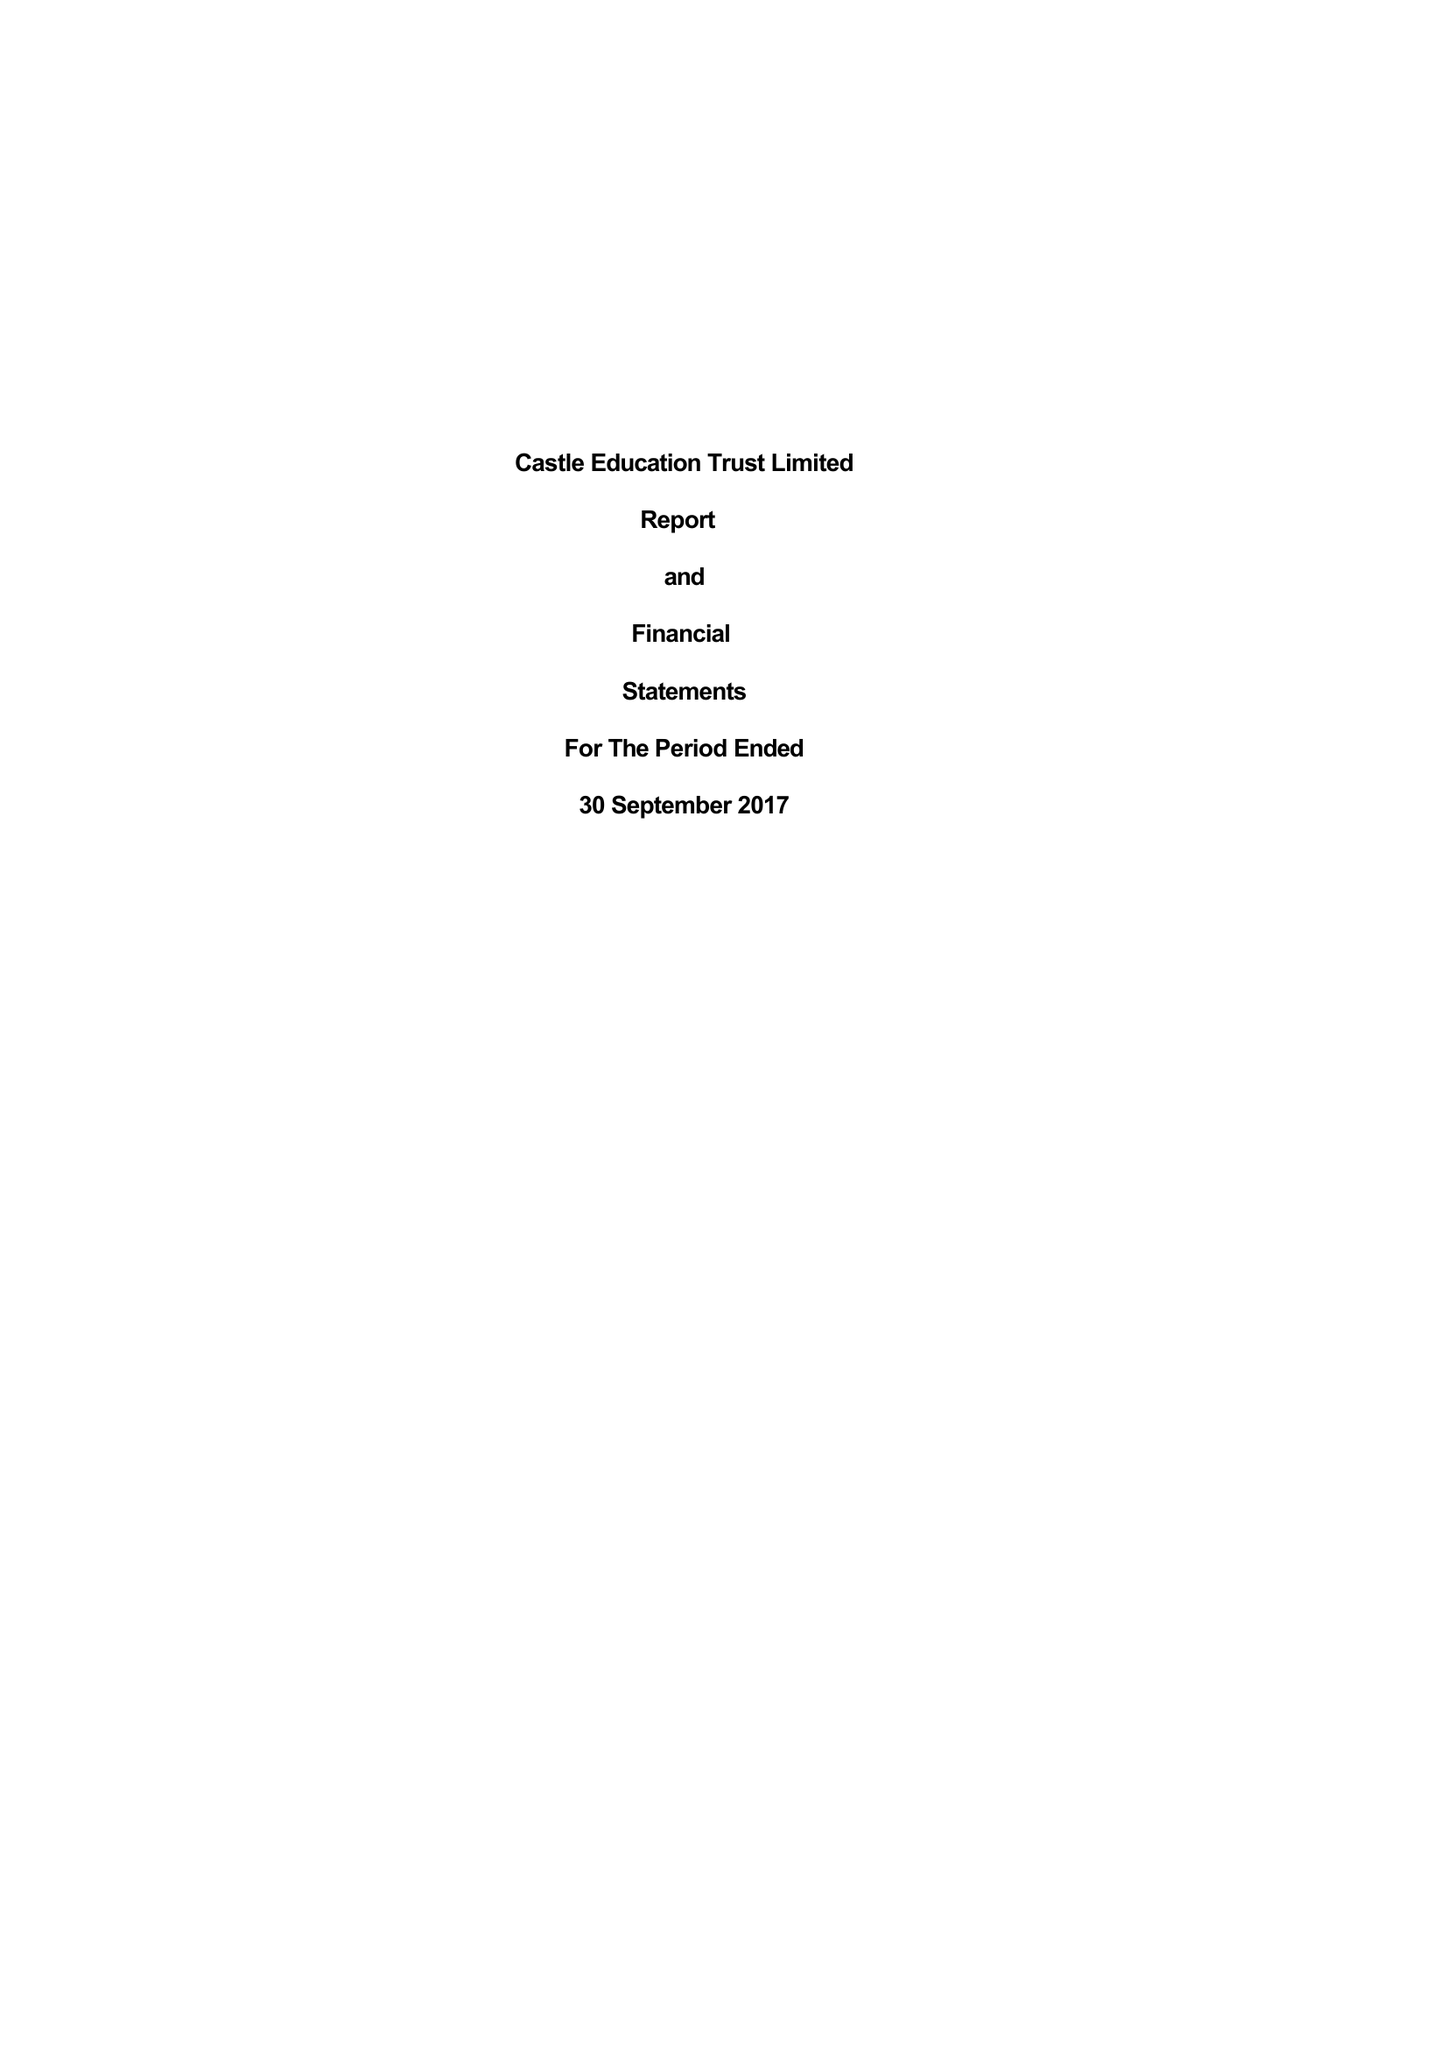What is the value for the charity_name?
Answer the question using a single word or phrase. Castle Education Trust Ltd. 